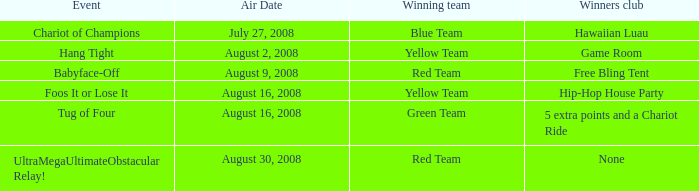Which victors club has an event of cling tight? Game Room. 